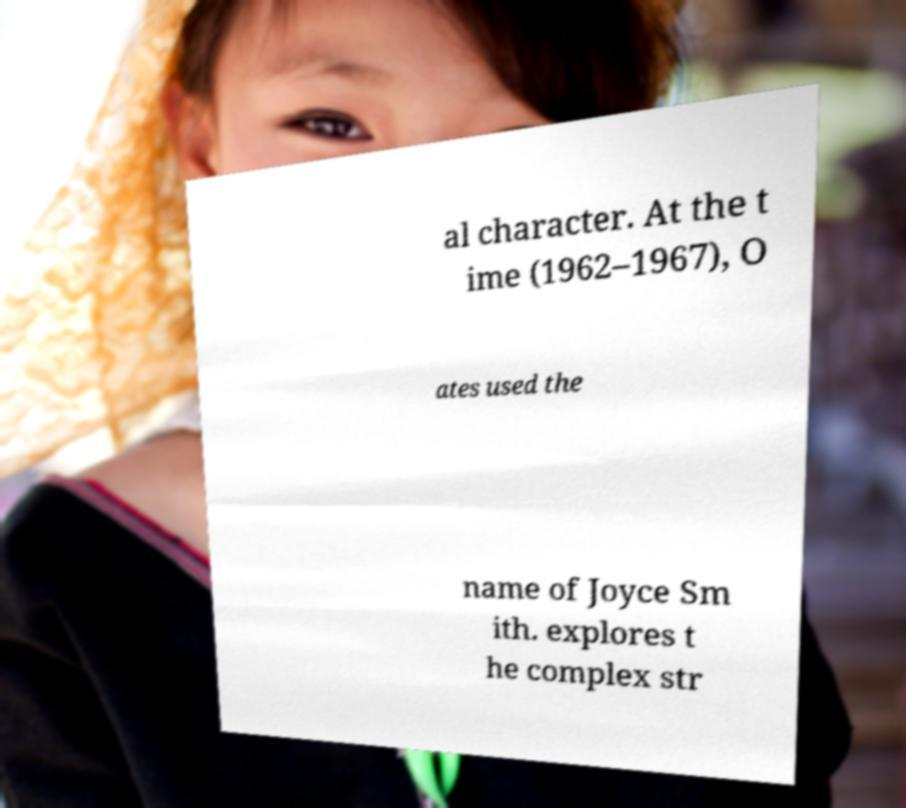Please identify and transcribe the text found in this image. al character. At the t ime (1962–1967), O ates used the name of Joyce Sm ith. explores t he complex str 